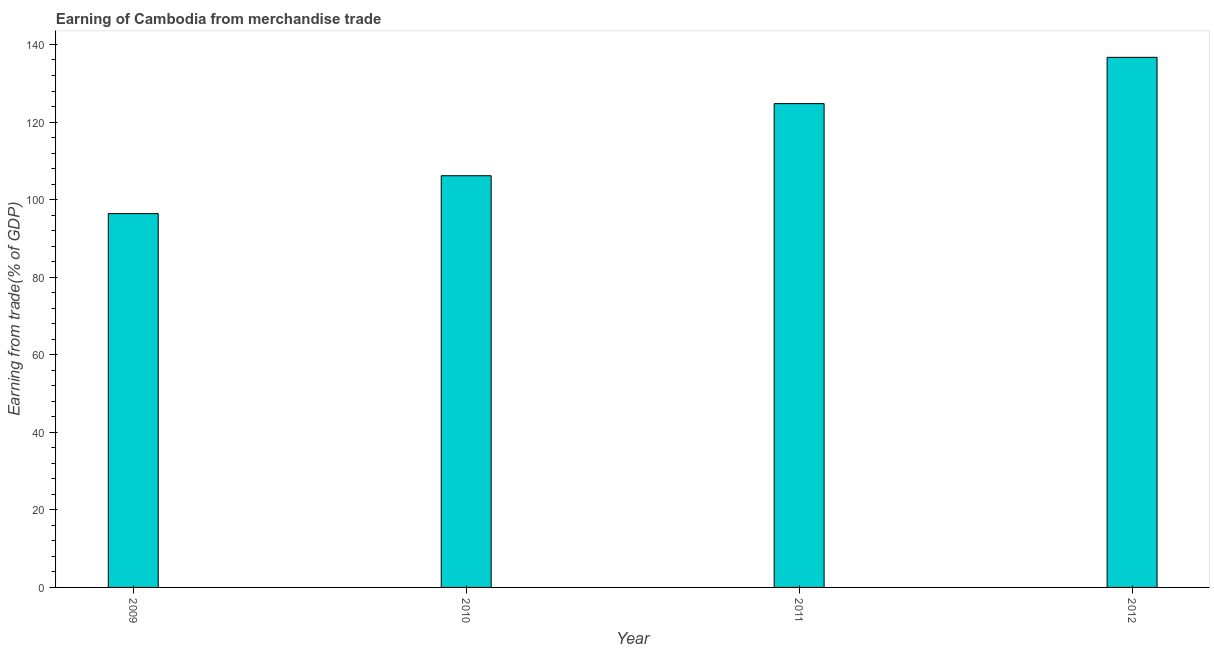Does the graph contain any zero values?
Provide a short and direct response. No. Does the graph contain grids?
Ensure brevity in your answer.  No. What is the title of the graph?
Your response must be concise. Earning of Cambodia from merchandise trade. What is the label or title of the Y-axis?
Keep it short and to the point. Earning from trade(% of GDP). What is the earning from merchandise trade in 2010?
Provide a short and direct response. 106.15. Across all years, what is the maximum earning from merchandise trade?
Provide a short and direct response. 136.68. Across all years, what is the minimum earning from merchandise trade?
Give a very brief answer. 96.39. In which year was the earning from merchandise trade maximum?
Your answer should be compact. 2012. In which year was the earning from merchandise trade minimum?
Keep it short and to the point. 2009. What is the sum of the earning from merchandise trade?
Your answer should be compact. 463.97. What is the difference between the earning from merchandise trade in 2009 and 2010?
Your answer should be very brief. -9.76. What is the average earning from merchandise trade per year?
Make the answer very short. 115.99. What is the median earning from merchandise trade?
Keep it short and to the point. 115.45. In how many years, is the earning from merchandise trade greater than 116 %?
Provide a succinct answer. 2. What is the ratio of the earning from merchandise trade in 2010 to that in 2011?
Offer a terse response. 0.85. Is the difference between the earning from merchandise trade in 2009 and 2010 greater than the difference between any two years?
Provide a short and direct response. No. What is the difference between the highest and the second highest earning from merchandise trade?
Provide a succinct answer. 11.94. What is the difference between the highest and the lowest earning from merchandise trade?
Your answer should be compact. 40.29. How many bars are there?
Provide a succinct answer. 4. How many years are there in the graph?
Give a very brief answer. 4. What is the difference between two consecutive major ticks on the Y-axis?
Keep it short and to the point. 20. What is the Earning from trade(% of GDP) of 2009?
Provide a short and direct response. 96.39. What is the Earning from trade(% of GDP) in 2010?
Ensure brevity in your answer.  106.15. What is the Earning from trade(% of GDP) in 2011?
Make the answer very short. 124.74. What is the Earning from trade(% of GDP) of 2012?
Offer a terse response. 136.68. What is the difference between the Earning from trade(% of GDP) in 2009 and 2010?
Provide a succinct answer. -9.76. What is the difference between the Earning from trade(% of GDP) in 2009 and 2011?
Keep it short and to the point. -28.35. What is the difference between the Earning from trade(% of GDP) in 2009 and 2012?
Offer a very short reply. -40.29. What is the difference between the Earning from trade(% of GDP) in 2010 and 2011?
Offer a very short reply. -18.59. What is the difference between the Earning from trade(% of GDP) in 2010 and 2012?
Ensure brevity in your answer.  -30.53. What is the difference between the Earning from trade(% of GDP) in 2011 and 2012?
Ensure brevity in your answer.  -11.94. What is the ratio of the Earning from trade(% of GDP) in 2009 to that in 2010?
Make the answer very short. 0.91. What is the ratio of the Earning from trade(% of GDP) in 2009 to that in 2011?
Offer a terse response. 0.77. What is the ratio of the Earning from trade(% of GDP) in 2009 to that in 2012?
Offer a very short reply. 0.7. What is the ratio of the Earning from trade(% of GDP) in 2010 to that in 2011?
Make the answer very short. 0.85. What is the ratio of the Earning from trade(% of GDP) in 2010 to that in 2012?
Provide a succinct answer. 0.78. What is the ratio of the Earning from trade(% of GDP) in 2011 to that in 2012?
Keep it short and to the point. 0.91. 